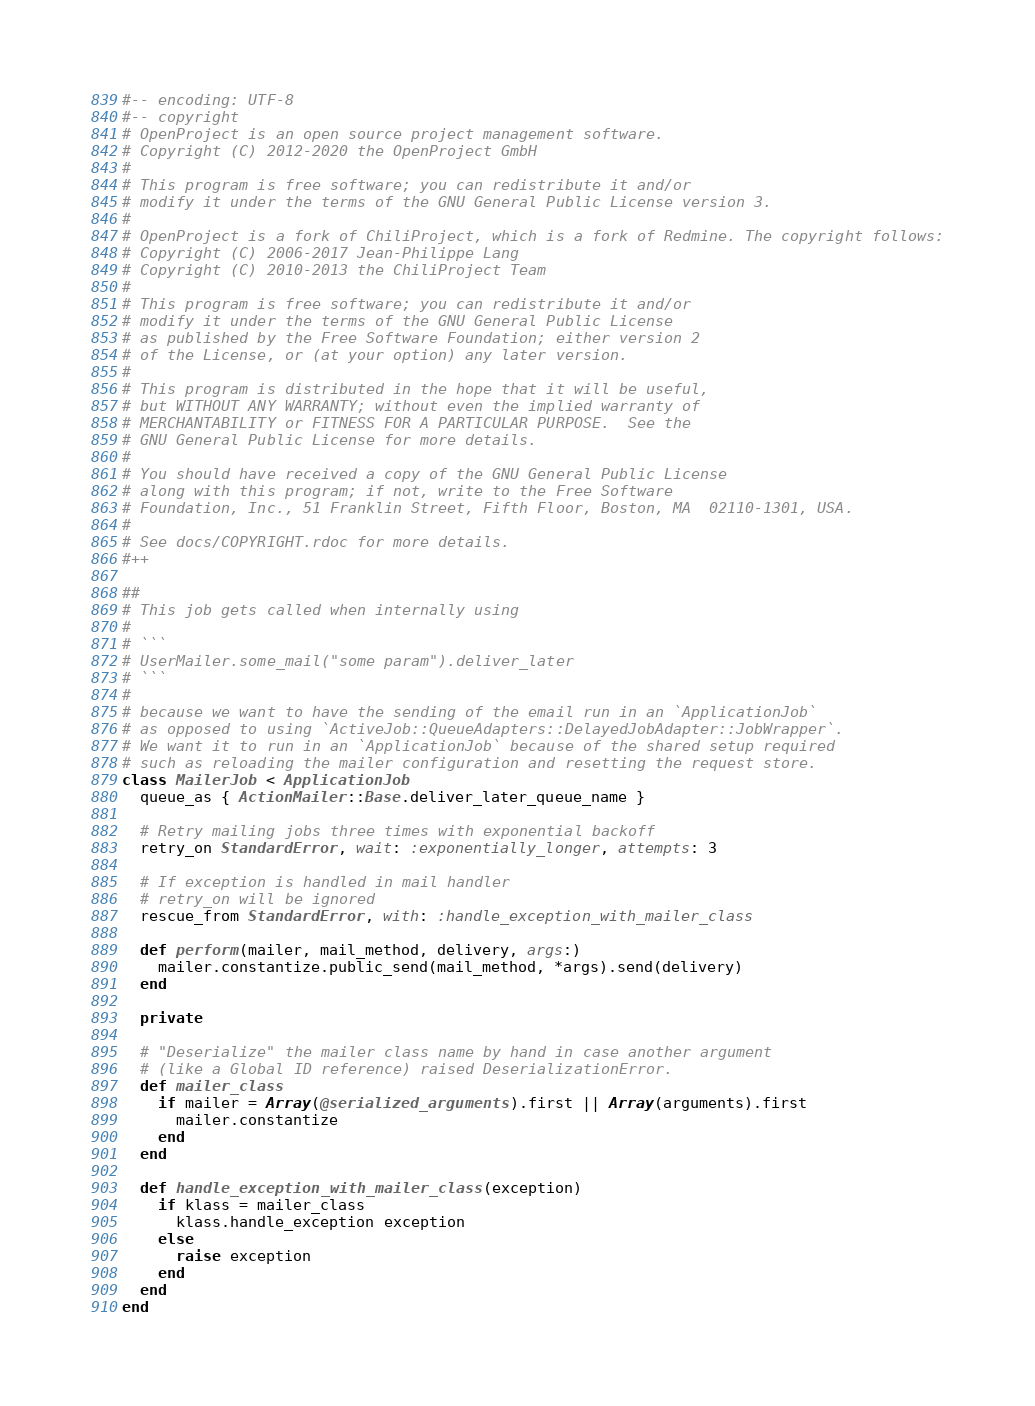<code> <loc_0><loc_0><loc_500><loc_500><_Ruby_>#-- encoding: UTF-8
#-- copyright
# OpenProject is an open source project management software.
# Copyright (C) 2012-2020 the OpenProject GmbH
#
# This program is free software; you can redistribute it and/or
# modify it under the terms of the GNU General Public License version 3.
#
# OpenProject is a fork of ChiliProject, which is a fork of Redmine. The copyright follows:
# Copyright (C) 2006-2017 Jean-Philippe Lang
# Copyright (C) 2010-2013 the ChiliProject Team
#
# This program is free software; you can redistribute it and/or
# modify it under the terms of the GNU General Public License
# as published by the Free Software Foundation; either version 2
# of the License, or (at your option) any later version.
#
# This program is distributed in the hope that it will be useful,
# but WITHOUT ANY WARRANTY; without even the implied warranty of
# MERCHANTABILITY or FITNESS FOR A PARTICULAR PURPOSE.  See the
# GNU General Public License for more details.
#
# You should have received a copy of the GNU General Public License
# along with this program; if not, write to the Free Software
# Foundation, Inc., 51 Franklin Street, Fifth Floor, Boston, MA  02110-1301, USA.
#
# See docs/COPYRIGHT.rdoc for more details.
#++

##
# This job gets called when internally using
#
# ```
# UserMailer.some_mail("some param").deliver_later
# ```
#
# because we want to have the sending of the email run in an `ApplicationJob`
# as opposed to using `ActiveJob::QueueAdapters::DelayedJobAdapter::JobWrapper`.
# We want it to run in an `ApplicationJob` because of the shared setup required
# such as reloading the mailer configuration and resetting the request store.
class MailerJob < ApplicationJob
  queue_as { ActionMailer::Base.deliver_later_queue_name }

  # Retry mailing jobs three times with exponential backoff
  retry_on StandardError, wait: :exponentially_longer, attempts: 3

  # If exception is handled in mail handler
  # retry_on will be ignored
  rescue_from StandardError, with: :handle_exception_with_mailer_class

  def perform(mailer, mail_method, delivery, args:)
    mailer.constantize.public_send(mail_method, *args).send(delivery)
  end

  private

  # "Deserialize" the mailer class name by hand in case another argument
  # (like a Global ID reference) raised DeserializationError.
  def mailer_class
    if mailer = Array(@serialized_arguments).first || Array(arguments).first
      mailer.constantize
    end
  end

  def handle_exception_with_mailer_class(exception)
    if klass = mailer_class
      klass.handle_exception exception
    else
      raise exception
    end
  end
end
</code> 